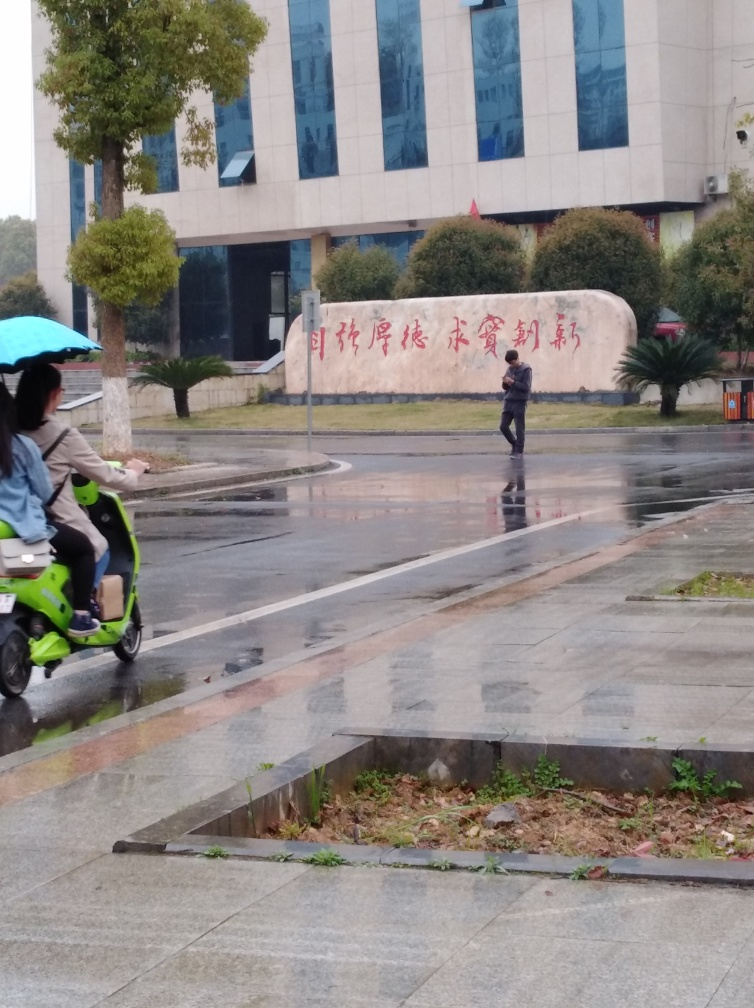What can you tell about the weather in the image? The weather appears to be overcast and rainy. The ground is wet, reflecting light from the surroundings, and there is a person walking cautiously, likely to avoid slipping. Additionally, a person is seen riding a scooter with a rain cover, further indicative of the rainy conditions. 